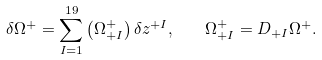<formula> <loc_0><loc_0><loc_500><loc_500>\delta \Omega ^ { + } = \sum _ { I = 1 } ^ { 1 9 } \left ( \Omega _ { + I } ^ { + } \right ) \delta z ^ { + I } , \quad \Omega _ { + I } ^ { + } = D _ { + I } \Omega ^ { + } .</formula> 